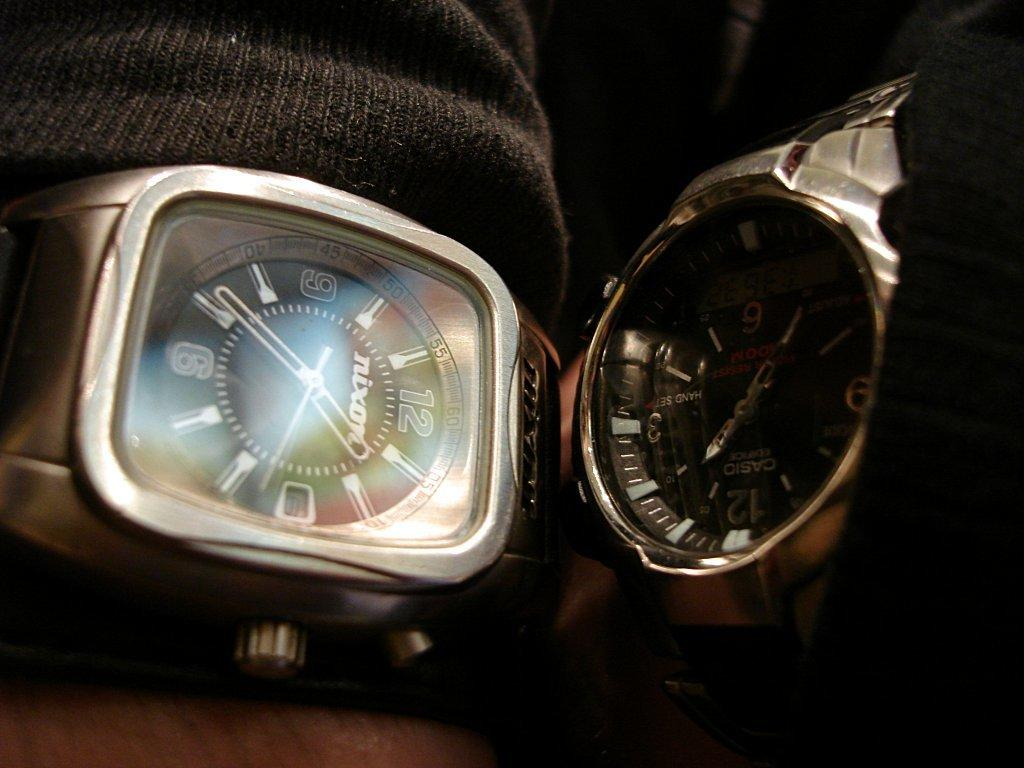<image>
Give a short and clear explanation of the subsequent image. A Nixon watch shows the numbers 12 and 6 on it 